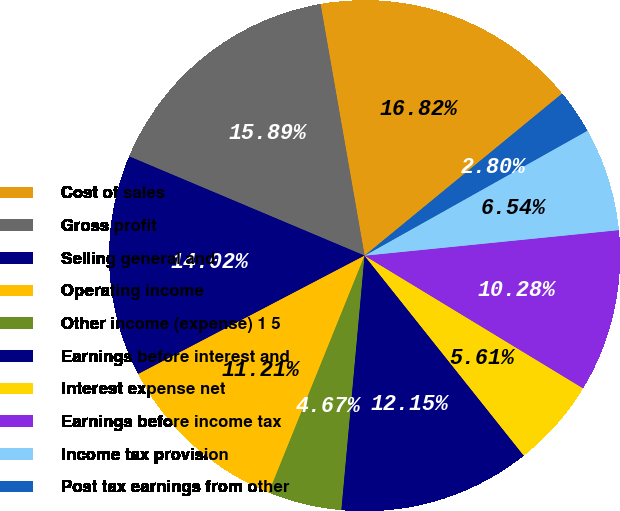Convert chart to OTSL. <chart><loc_0><loc_0><loc_500><loc_500><pie_chart><fcel>Cost of sales<fcel>Gross profit<fcel>Selling general and<fcel>Operating income<fcel>Other income (expense) 1 5<fcel>Earnings before interest and<fcel>Interest expense net<fcel>Earnings before income tax<fcel>Income tax provision<fcel>Post tax earnings from other<nl><fcel>16.82%<fcel>15.89%<fcel>14.02%<fcel>11.21%<fcel>4.67%<fcel>12.15%<fcel>5.61%<fcel>10.28%<fcel>6.54%<fcel>2.8%<nl></chart> 